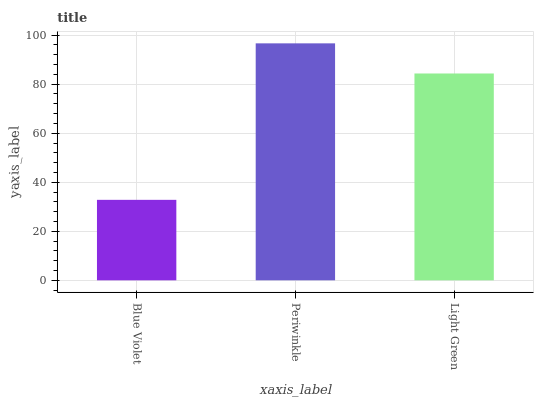Is Blue Violet the minimum?
Answer yes or no. Yes. Is Periwinkle the maximum?
Answer yes or no. Yes. Is Light Green the minimum?
Answer yes or no. No. Is Light Green the maximum?
Answer yes or no. No. Is Periwinkle greater than Light Green?
Answer yes or no. Yes. Is Light Green less than Periwinkle?
Answer yes or no. Yes. Is Light Green greater than Periwinkle?
Answer yes or no. No. Is Periwinkle less than Light Green?
Answer yes or no. No. Is Light Green the high median?
Answer yes or no. Yes. Is Light Green the low median?
Answer yes or no. Yes. Is Blue Violet the high median?
Answer yes or no. No. Is Periwinkle the low median?
Answer yes or no. No. 